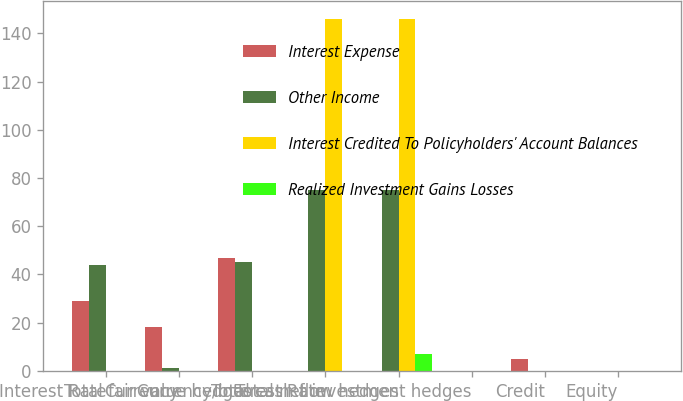Convert chart to OTSL. <chart><loc_0><loc_0><loc_500><loc_500><stacked_bar_chart><ecel><fcel>Interest Rate<fcel>Currency<fcel>Total fair value hedges<fcel>Currency/Interest Rate<fcel>Total cash flow hedges<fcel>Total net investment hedges<fcel>Credit<fcel>Equity<nl><fcel>Interest Expense<fcel>29<fcel>18<fcel>47<fcel>0<fcel>0<fcel>0<fcel>5<fcel>0<nl><fcel>Other Income<fcel>44<fcel>1<fcel>45<fcel>75<fcel>75<fcel>0<fcel>0<fcel>0<nl><fcel>Interest Credited To Policyholders' Account Balances<fcel>0<fcel>0<fcel>0<fcel>146<fcel>146<fcel>0<fcel>0<fcel>0<nl><fcel>Realized Investment Gains Losses<fcel>0<fcel>0<fcel>0<fcel>0<fcel>7<fcel>0<fcel>0<fcel>0<nl></chart> 